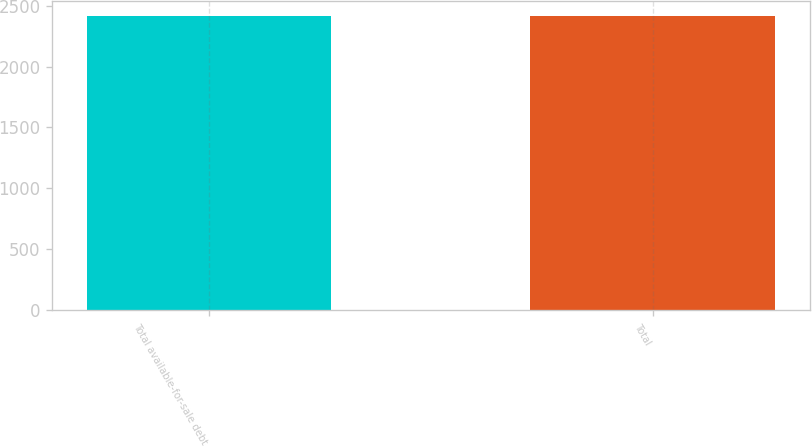Convert chart to OTSL. <chart><loc_0><loc_0><loc_500><loc_500><bar_chart><fcel>Total available-for-sale debt<fcel>Total<nl><fcel>2418.8<fcel>2418.9<nl></chart> 